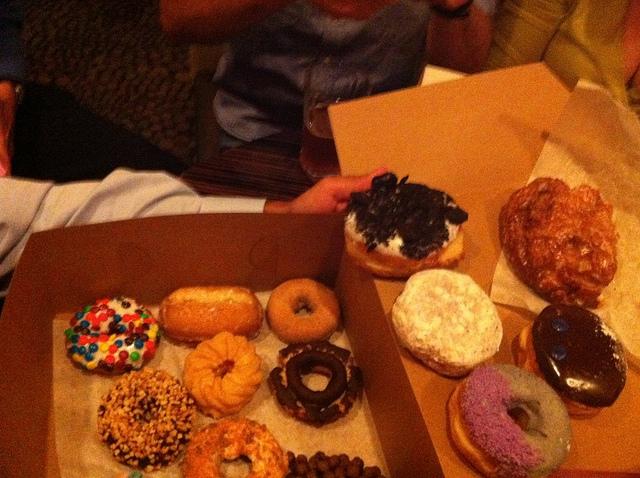What topping in the donut to the upper left of the photo?
Short answer required. M&m's. How many chocolate donuts are there?
Be succinct. 3. Is this a children's toy?
Be succinct. No. Is there a cruller in the box?
Be succinct. Yes. 